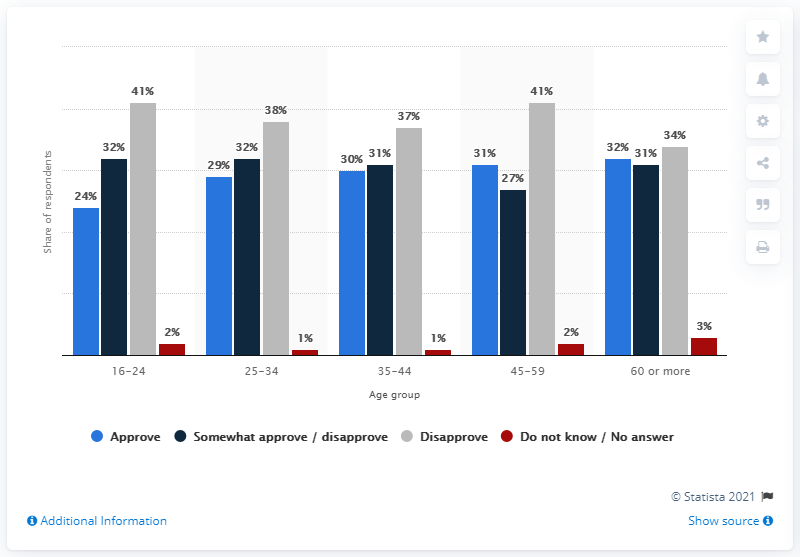Give some essential details in this illustration. The average of people who answered "approve" is 29.2% in the given context. The color red is used on the graph to denote a specific meaning, but the individual is unable to identify which specific meaning it represents. 